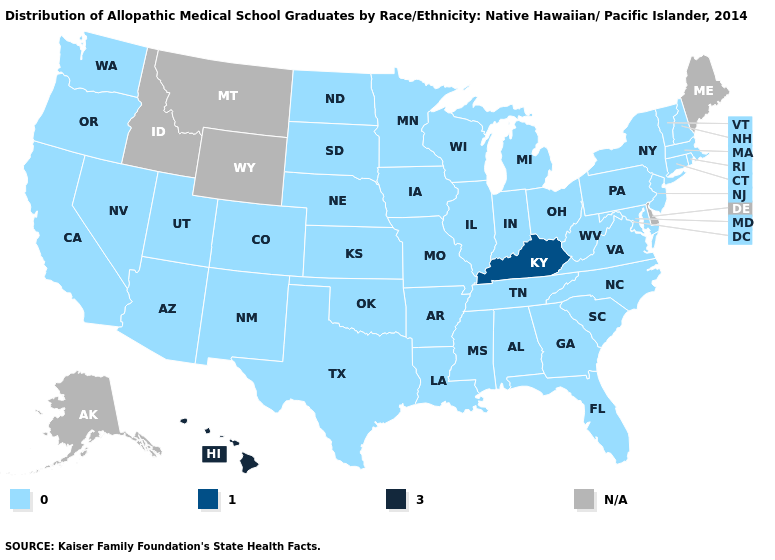Among the states that border Rhode Island , which have the highest value?
Answer briefly. Connecticut, Massachusetts. Name the states that have a value in the range 0.0?
Concise answer only. Alabama, Arizona, Arkansas, California, Colorado, Connecticut, Florida, Georgia, Illinois, Indiana, Iowa, Kansas, Louisiana, Maryland, Massachusetts, Michigan, Minnesota, Mississippi, Missouri, Nebraska, Nevada, New Hampshire, New Jersey, New Mexico, New York, North Carolina, North Dakota, Ohio, Oklahoma, Oregon, Pennsylvania, Rhode Island, South Carolina, South Dakota, Tennessee, Texas, Utah, Vermont, Virginia, Washington, West Virginia, Wisconsin. Does Hawaii have the highest value in the West?
Be succinct. Yes. What is the highest value in the MidWest ?
Write a very short answer. 0.0. Name the states that have a value in the range 3.0?
Give a very brief answer. Hawaii. Name the states that have a value in the range N/A?
Write a very short answer. Alaska, Delaware, Idaho, Maine, Montana, Wyoming. What is the value of Florida?
Keep it brief. 0.0. Which states have the lowest value in the USA?
Give a very brief answer. Alabama, Arizona, Arkansas, California, Colorado, Connecticut, Florida, Georgia, Illinois, Indiana, Iowa, Kansas, Louisiana, Maryland, Massachusetts, Michigan, Minnesota, Mississippi, Missouri, Nebraska, Nevada, New Hampshire, New Jersey, New Mexico, New York, North Carolina, North Dakota, Ohio, Oklahoma, Oregon, Pennsylvania, Rhode Island, South Carolina, South Dakota, Tennessee, Texas, Utah, Vermont, Virginia, Washington, West Virginia, Wisconsin. What is the highest value in states that border Kansas?
Concise answer only. 0.0. Name the states that have a value in the range 0.0?
Short answer required. Alabama, Arizona, Arkansas, California, Colorado, Connecticut, Florida, Georgia, Illinois, Indiana, Iowa, Kansas, Louisiana, Maryland, Massachusetts, Michigan, Minnesota, Mississippi, Missouri, Nebraska, Nevada, New Hampshire, New Jersey, New Mexico, New York, North Carolina, North Dakota, Ohio, Oklahoma, Oregon, Pennsylvania, Rhode Island, South Carolina, South Dakota, Tennessee, Texas, Utah, Vermont, Virginia, Washington, West Virginia, Wisconsin. Does the map have missing data?
Keep it brief. Yes. Which states have the lowest value in the South?
Concise answer only. Alabama, Arkansas, Florida, Georgia, Louisiana, Maryland, Mississippi, North Carolina, Oklahoma, South Carolina, Tennessee, Texas, Virginia, West Virginia. Name the states that have a value in the range 0.0?
Write a very short answer. Alabama, Arizona, Arkansas, California, Colorado, Connecticut, Florida, Georgia, Illinois, Indiana, Iowa, Kansas, Louisiana, Maryland, Massachusetts, Michigan, Minnesota, Mississippi, Missouri, Nebraska, Nevada, New Hampshire, New Jersey, New Mexico, New York, North Carolina, North Dakota, Ohio, Oklahoma, Oregon, Pennsylvania, Rhode Island, South Carolina, South Dakota, Tennessee, Texas, Utah, Vermont, Virginia, Washington, West Virginia, Wisconsin. Does Hawaii have the highest value in the USA?
Keep it brief. Yes. Is the legend a continuous bar?
Short answer required. No. 